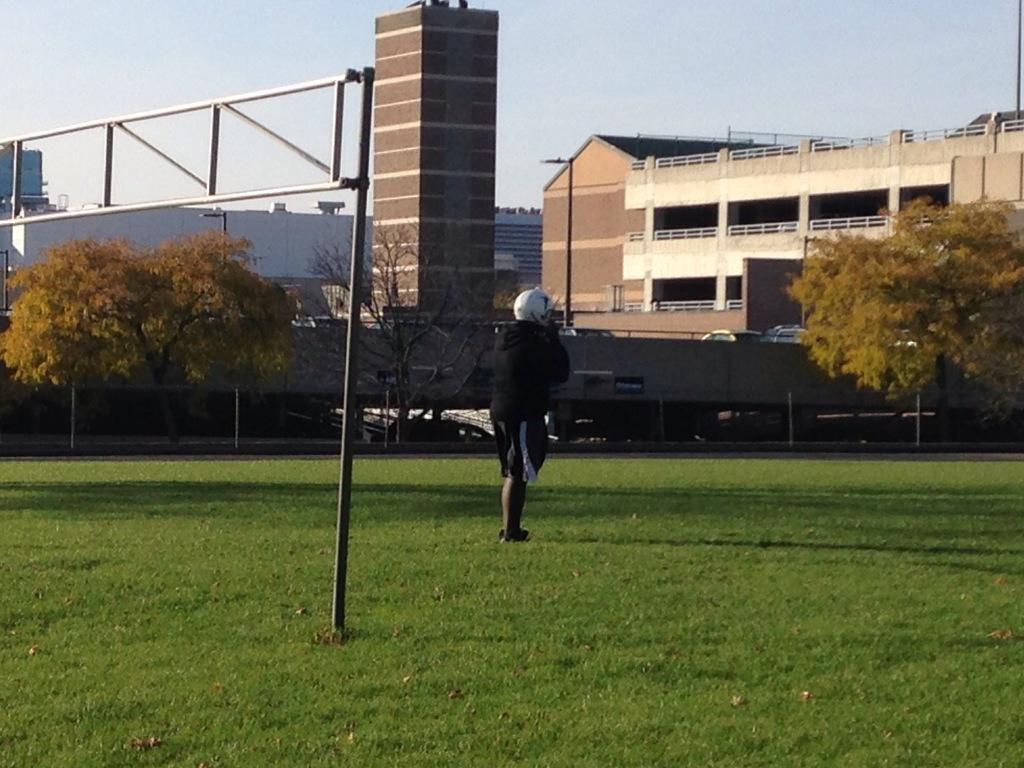What type of vegetation can be seen in the image? There is grass in the image. Can you describe the person in the image? There is a person in the image. What can be seen in the background of the image? There are trees and buildings in the background of the image. What part of the natural environment is visible in the image? The sky is visible in the background of the image. What is the size of the aftermath in the image? There is no aftermath present in the image. 